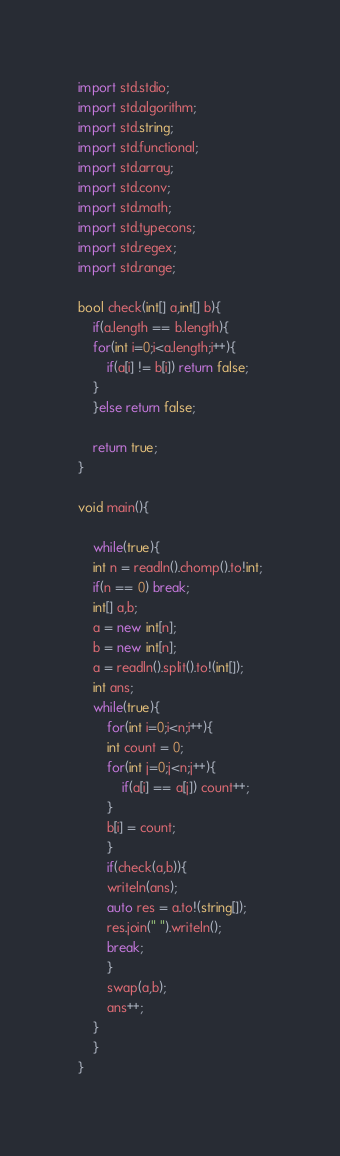Convert code to text. <code><loc_0><loc_0><loc_500><loc_500><_D_>import std.stdio;
import std.algorithm;
import std.string;
import std.functional;
import std.array;
import std.conv;
import std.math;
import std.typecons;
import std.regex;
import std.range;

bool check(int[] a,int[] b){
    if(a.length == b.length){
	for(int i=0;i<a.length;i++){
	    if(a[i] != b[i]) return false;
	}
    }else return false;

    return true;
}

void main(){

    while(true){
	int n = readln().chomp().to!int;
	if(n == 0) break;
	int[] a,b;
	a = new int[n];
	b = new int[n];
	a = readln().split().to!(int[]);
	int ans;
	while(true){
	    for(int i=0;i<n;i++){
		int count = 0;
		for(int j=0;j<n;j++){
		    if(a[i] == a[j]) count++;
		}
		b[i] = count;
	    }
	    if(check(a,b)){
		writeln(ans);
		auto res = a.to!(string[]);
		res.join(" ").writeln();
		break;
	    }
	    swap(a,b);
	    ans++;
	}
    }
}</code> 